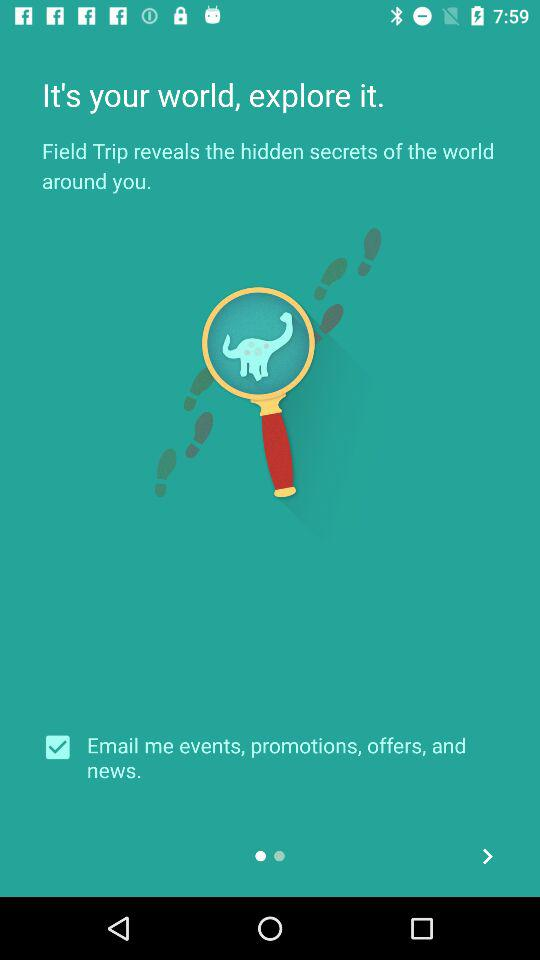What is the status of "Email me events, promotions, offers, and news."? The status is "on". 